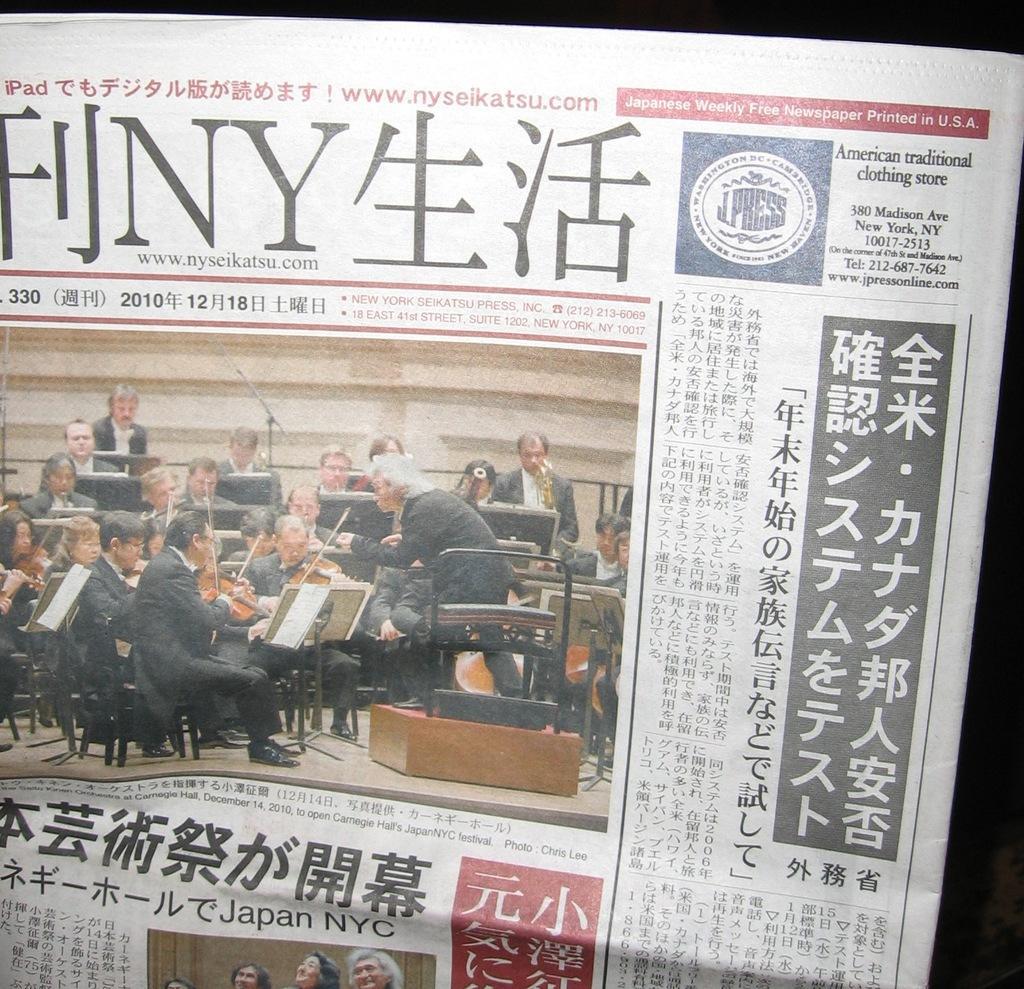Could you give a brief overview of what you see in this image? In this image we can see a paper with the text and also the people. 